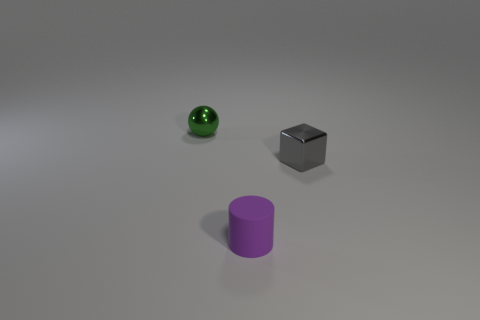What is the shape of the thing behind the shiny object that is in front of the green sphere?
Your answer should be compact. Sphere. There is a metallic object in front of the tiny object behind the gray metal cube; how many objects are in front of it?
Provide a short and direct response. 1. Are there fewer purple rubber objects that are on the left side of the green metal thing than small gray things?
Provide a short and direct response. Yes. Is there anything else that is the same shape as the purple object?
Your answer should be compact. No. What shape is the thing that is in front of the gray cube?
Your answer should be very brief. Cylinder. The tiny thing that is left of the thing in front of the shiny thing right of the green metallic ball is what shape?
Make the answer very short. Sphere. How many objects are either purple cylinders or small brown shiny balls?
Keep it short and to the point. 1. What number of small objects are in front of the small gray thing and on the left side of the tiny purple cylinder?
Your answer should be compact. 0. What number of other objects are there of the same size as the cube?
Your response must be concise. 2. What is the material of the small object that is both to the right of the small sphere and on the left side of the cube?
Your answer should be very brief. Rubber. 